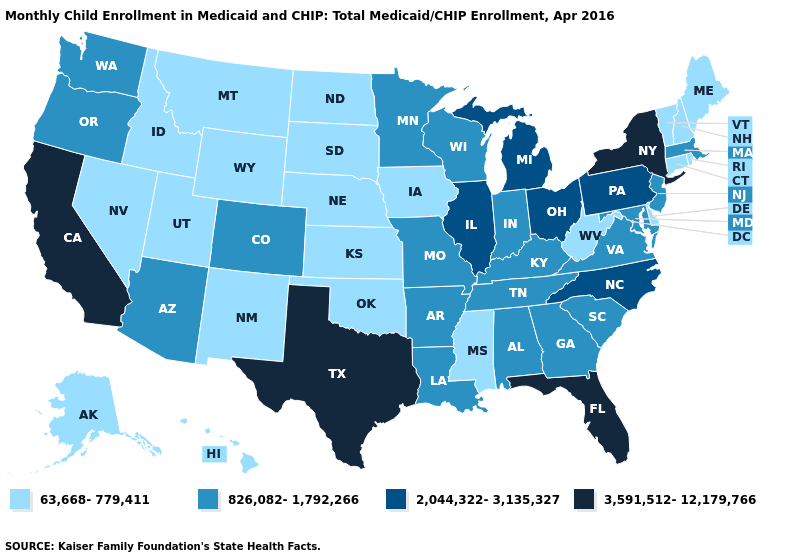Does the map have missing data?
Short answer required. No. Among the states that border Wyoming , does Colorado have the lowest value?
Be succinct. No. Does the map have missing data?
Concise answer only. No. What is the value of Virginia?
Write a very short answer. 826,082-1,792,266. Among the states that border Rhode Island , which have the highest value?
Keep it brief. Massachusetts. Name the states that have a value in the range 3,591,512-12,179,766?
Keep it brief. California, Florida, New York, Texas. What is the lowest value in the USA?
Give a very brief answer. 63,668-779,411. Does the map have missing data?
Be succinct. No. What is the lowest value in the USA?
Write a very short answer. 63,668-779,411. Does Texas have the highest value in the USA?
Answer briefly. Yes. What is the value of Alaska?
Answer briefly. 63,668-779,411. Which states have the lowest value in the South?
Short answer required. Delaware, Mississippi, Oklahoma, West Virginia. Name the states that have a value in the range 3,591,512-12,179,766?
Keep it brief. California, Florida, New York, Texas. What is the value of South Dakota?
Answer briefly. 63,668-779,411. What is the highest value in states that border Arkansas?
Concise answer only. 3,591,512-12,179,766. 